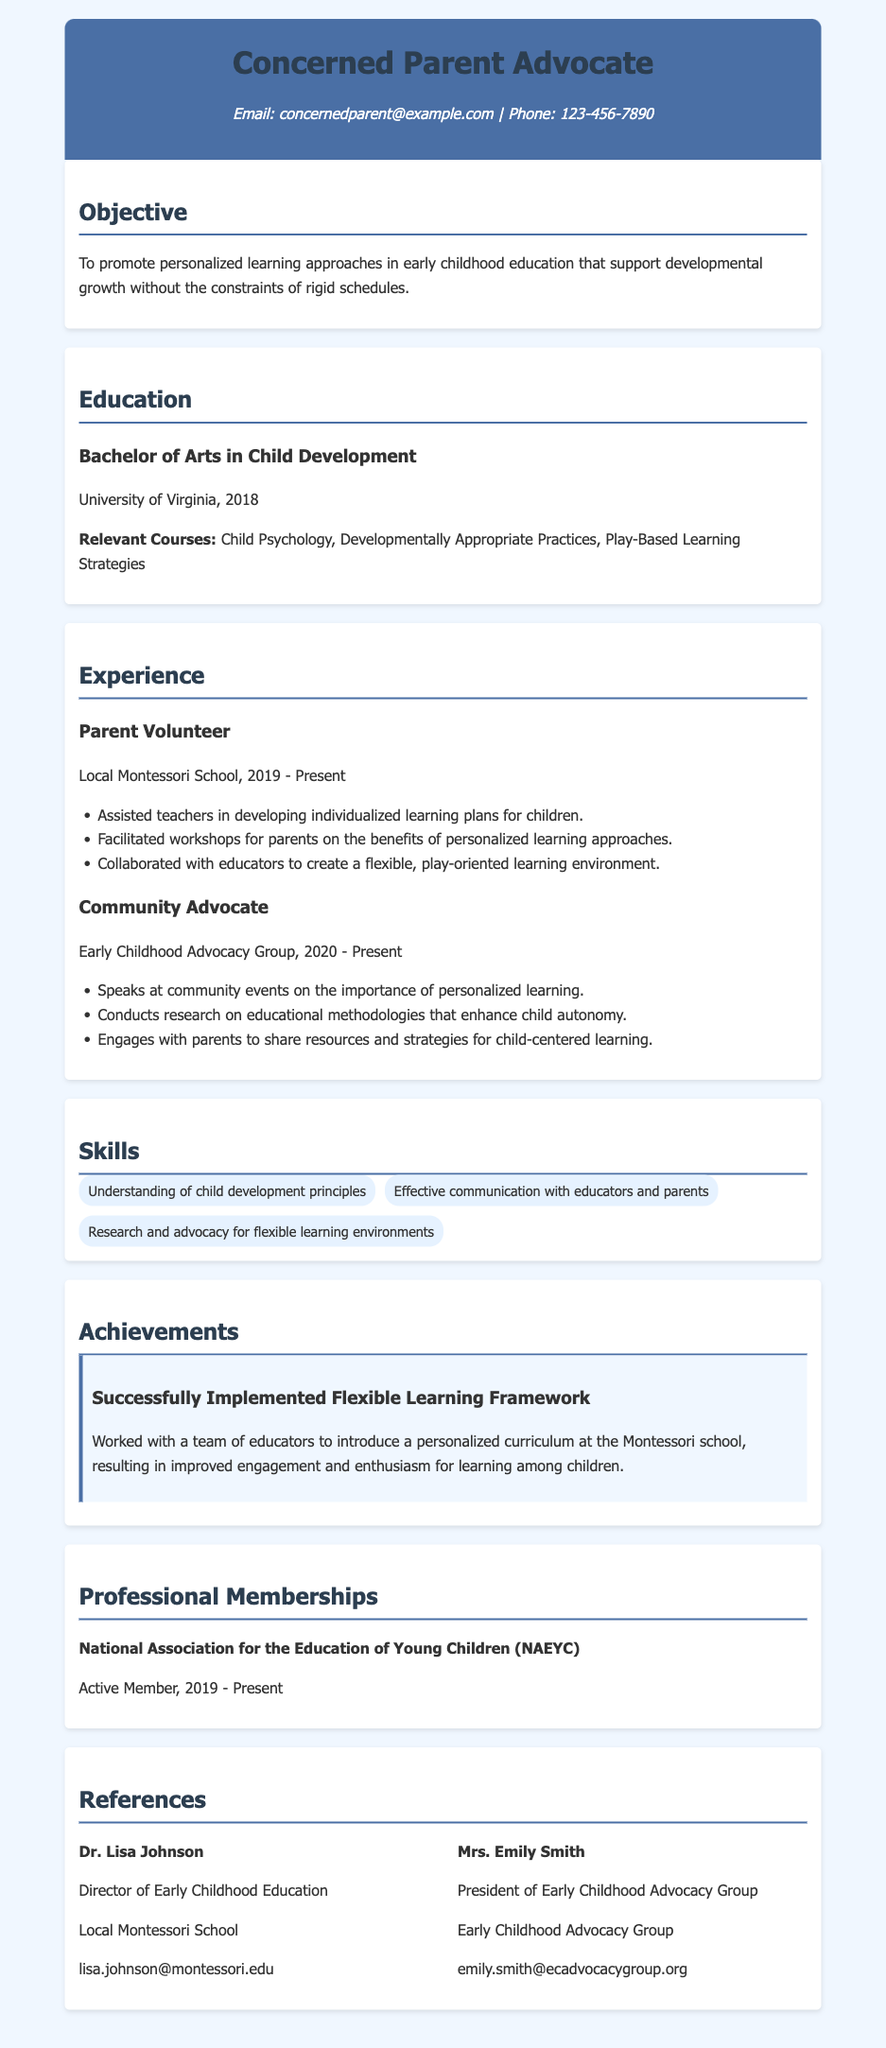What is the objective of the CV? The objective is stated in the document and highlights the aim to promote personalized learning approaches in early childhood education.
Answer: To promote personalized learning approaches in early childhood education that support developmental growth without the constraints of rigid schedules Where did the author complete their Bachelor of Arts? The document specifies the university where the author completed their degree.
Answer: University of Virginia What is one relevant course mentioned in the education section? The relevant courses listed under education highlight the author's academic background related to child development.
Answer: Child Psychology What year did the author start volunteering at the Local Montessori School? The experience section provides the starting year for the author's volunteer work at the specified location.
Answer: 2019 What role does the author hold in the Early Childhood Advocacy Group? The experience section identifies the author's position within the advocacy group.
Answer: Community Advocate Which professional association is the author a member of? The professional memberships section lists the association related to the author's career.
Answer: National Association for the Education of Young Children (NAEYC) What achievement is highlighted in the CV? The achievements section describes a significant accomplishment related to the author's advocacy and educational efforts.
Answer: Successfully Implemented Flexible Learning Framework Who is listed as a reference from the Local Montessori School? The references section provides contact information for individuals who can vouch for the author's qualifications.
Answer: Dr. Lisa Johnson 